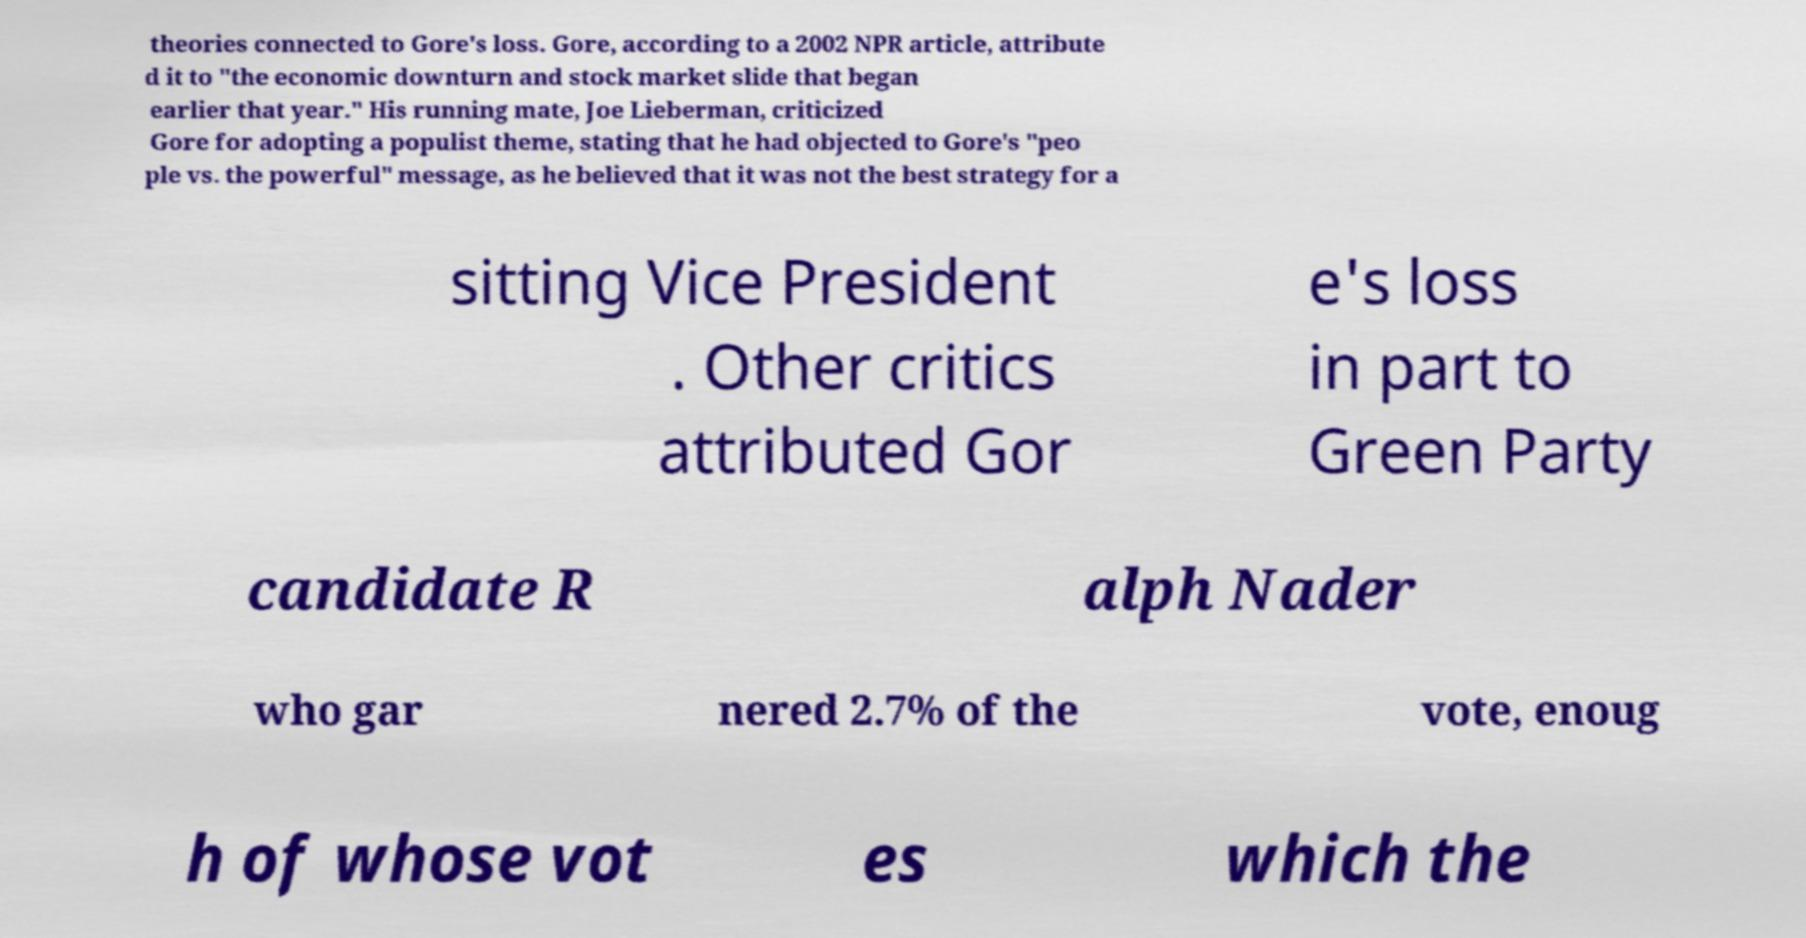There's text embedded in this image that I need extracted. Can you transcribe it verbatim? theories connected to Gore's loss. Gore, according to a 2002 NPR article, attribute d it to "the economic downturn and stock market slide that began earlier that year." His running mate, Joe Lieberman, criticized Gore for adopting a populist theme, stating that he had objected to Gore's "peo ple vs. the powerful" message, as he believed that it was not the best strategy for a sitting Vice President . Other critics attributed Gor e's loss in part to Green Party candidate R alph Nader who gar nered 2.7% of the vote, enoug h of whose vot es which the 